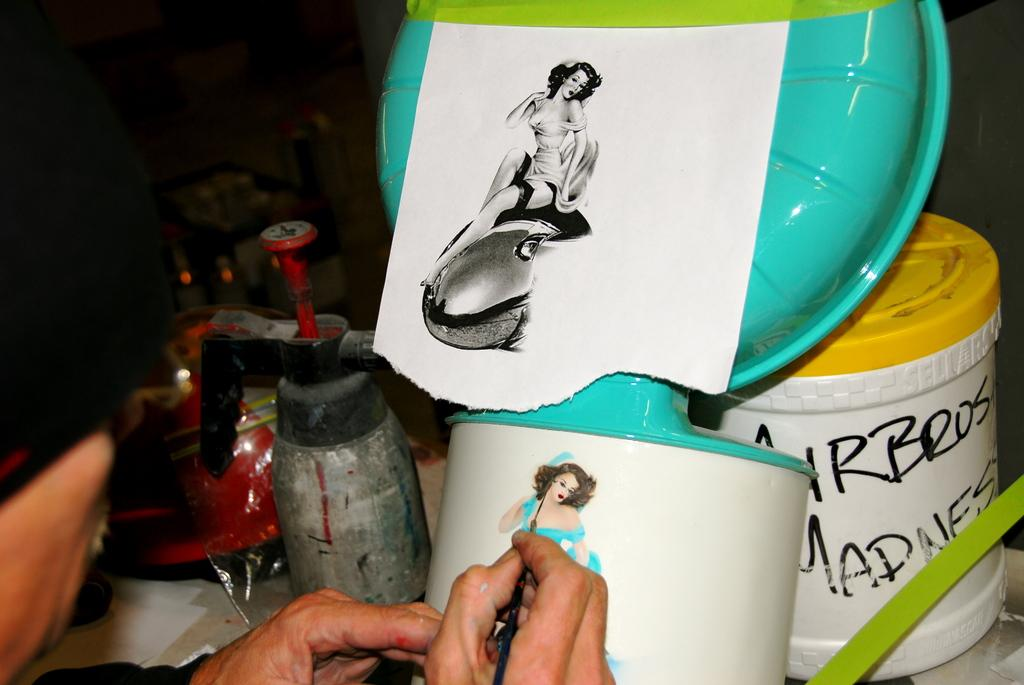What is the person in the image doing? The person in the image is painting. Can you describe any other objects in the image besides the person? Yes, there are other objects in the foreground of the image. What type of flowers are on the calendar in the image? There is no calendar or flowers present in the image. 